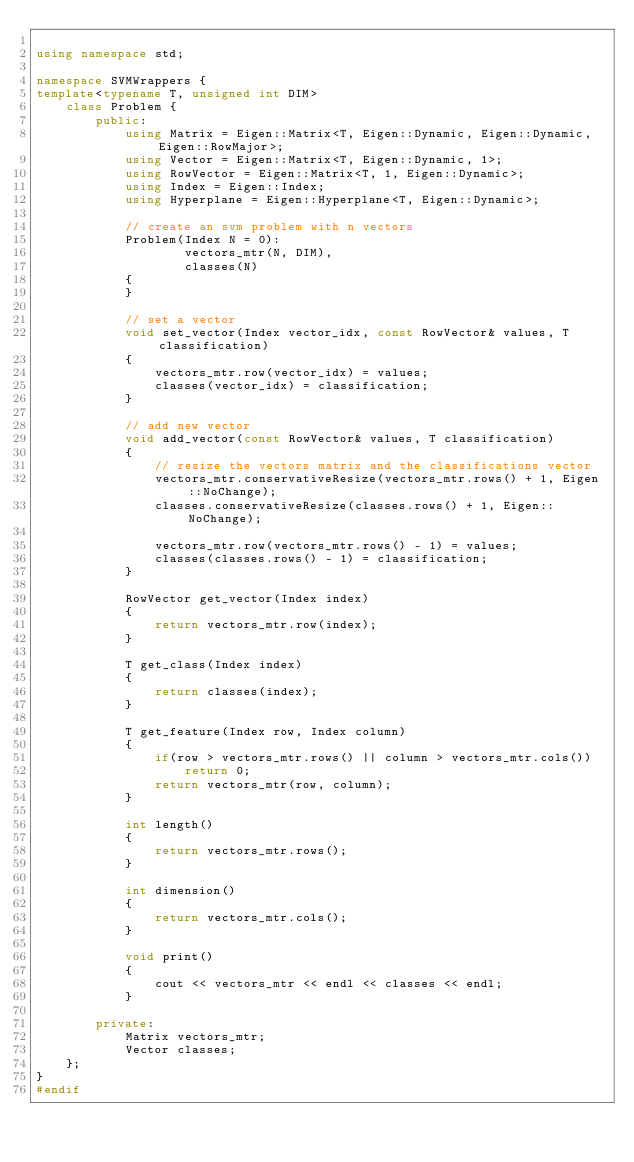<code> <loc_0><loc_0><loc_500><loc_500><_C++_>
using namespace std;

namespace SVMWrappers {
template<typename T, unsigned int DIM>
    class Problem {
        public:
            using Matrix = Eigen::Matrix<T, Eigen::Dynamic, Eigen::Dynamic, Eigen::RowMajor>;
            using Vector = Eigen::Matrix<T, Eigen::Dynamic, 1>;
            using RowVector = Eigen::Matrix<T, 1, Eigen::Dynamic>;
            using Index = Eigen::Index;
            using Hyperplane = Eigen::Hyperplane<T, Eigen::Dynamic>;

            // create an svm problem with n vectors
            Problem(Index N = 0):
                    vectors_mtr(N, DIM),
                    classes(N)
            {
            }

            // set a vector
            void set_vector(Index vector_idx, const RowVector& values, T classification)
            {
                vectors_mtr.row(vector_idx) = values;
                classes(vector_idx) = classification;
            }

            // add new vector
            void add_vector(const RowVector& values, T classification)
            {
                // resize the vectors matrix and the classifications vector
                vectors_mtr.conservativeResize(vectors_mtr.rows() + 1, Eigen::NoChange);
                classes.conservativeResize(classes.rows() + 1, Eigen::NoChange);
                
                vectors_mtr.row(vectors_mtr.rows() - 1) = values;
                classes(classes.rows() - 1) = classification;
            }

            RowVector get_vector(Index index)
            {
                return vectors_mtr.row(index);
            }

            T get_class(Index index)
            {
                return classes(index);
            }

            T get_feature(Index row, Index column)
            {
                if(row > vectors_mtr.rows() || column > vectors_mtr.cols())
                    return 0;
                return vectors_mtr(row, column);
            }

            int length()
            {
                return vectors_mtr.rows();
            }

            int dimension()
            {
                return vectors_mtr.cols();
            }

            void print()
            {
                cout << vectors_mtr << endl << classes << endl;
            }

        private:
            Matrix vectors_mtr;
            Vector classes;
    };
}
#endif</code> 